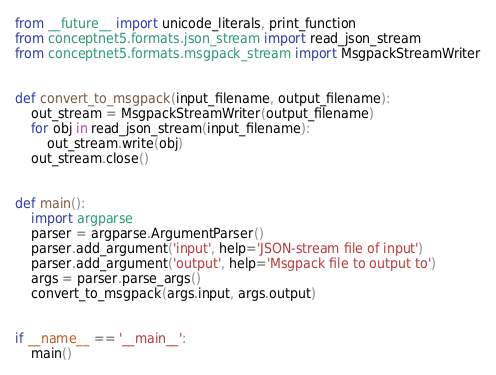<code> <loc_0><loc_0><loc_500><loc_500><_Python_>from __future__ import unicode_literals, print_function
from conceptnet5.formats.json_stream import read_json_stream
from conceptnet5.formats.msgpack_stream import MsgpackStreamWriter


def convert_to_msgpack(input_filename, output_filename):
    out_stream = MsgpackStreamWriter(output_filename)
    for obj in read_json_stream(input_filename):
        out_stream.write(obj)
    out_stream.close()


def main():
    import argparse
    parser = argparse.ArgumentParser()
    parser.add_argument('input', help='JSON-stream file of input')
    parser.add_argument('output', help='Msgpack file to output to')
    args = parser.parse_args()
    convert_to_msgpack(args.input, args.output)


if __name__ == '__main__':
    main()
</code> 